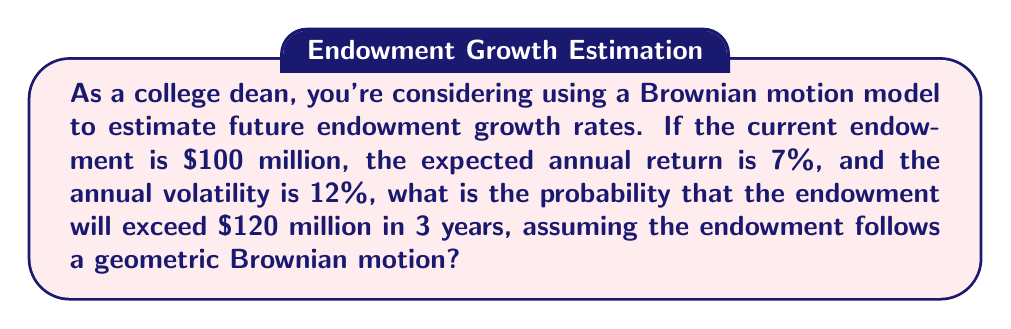Teach me how to tackle this problem. Let's approach this step-by-step using the geometric Brownian motion model:

1) The formula for geometric Brownian motion is:

   $$S_t = S_0 \exp\left(\left(\mu - \frac{\sigma^2}{2}\right)t + \sigma W_t\right)$$

   Where:
   $S_t$ is the value at time $t$
   $S_0$ is the initial value
   $\mu$ is the drift (expected return)
   $\sigma$ is the volatility
   $W_t$ is a Wiener process

2) We're interested in $P(S_3 > 120)$ given $S_0 = 100$, $\mu = 0.07$, $\sigma = 0.12$, and $t = 3$.

3) For a lognormal distribution, we can calculate this probability using:

   $$P(S_t > K) = N\left(\frac{\ln(S_0/K) + (\mu - \frac{\sigma^2}{2})t}{\sigma\sqrt{t}}\right)$$

   Where $N()$ is the cumulative standard normal distribution function.

4) Let's calculate the components:

   $$\ln(S_0/K) = \ln(100/120) = -0.1823$$
   $$(\mu - \frac{\sigma^2}{2})t = (0.07 - \frac{0.12^2}{2}) * 3 = 0.1764$$
   $$\sigma\sqrt{t} = 0.12\sqrt{3} = 0.2078$$

5) Putting it all together:

   $$\frac{-0.1823 + 0.1764}{0.2078} = -0.0284$$

6) Now we need to find $N(-0.0284)$. Using a standard normal table or calculator:

   $$N(-0.0284) \approx 0.4887$$

7) The probability we're looking for is $1 - 0.4887 = 0.5113$

Therefore, the probability that the endowment will exceed $120 million in 3 years is approximately 0.5113 or 51.13%.
Answer: 0.5113 